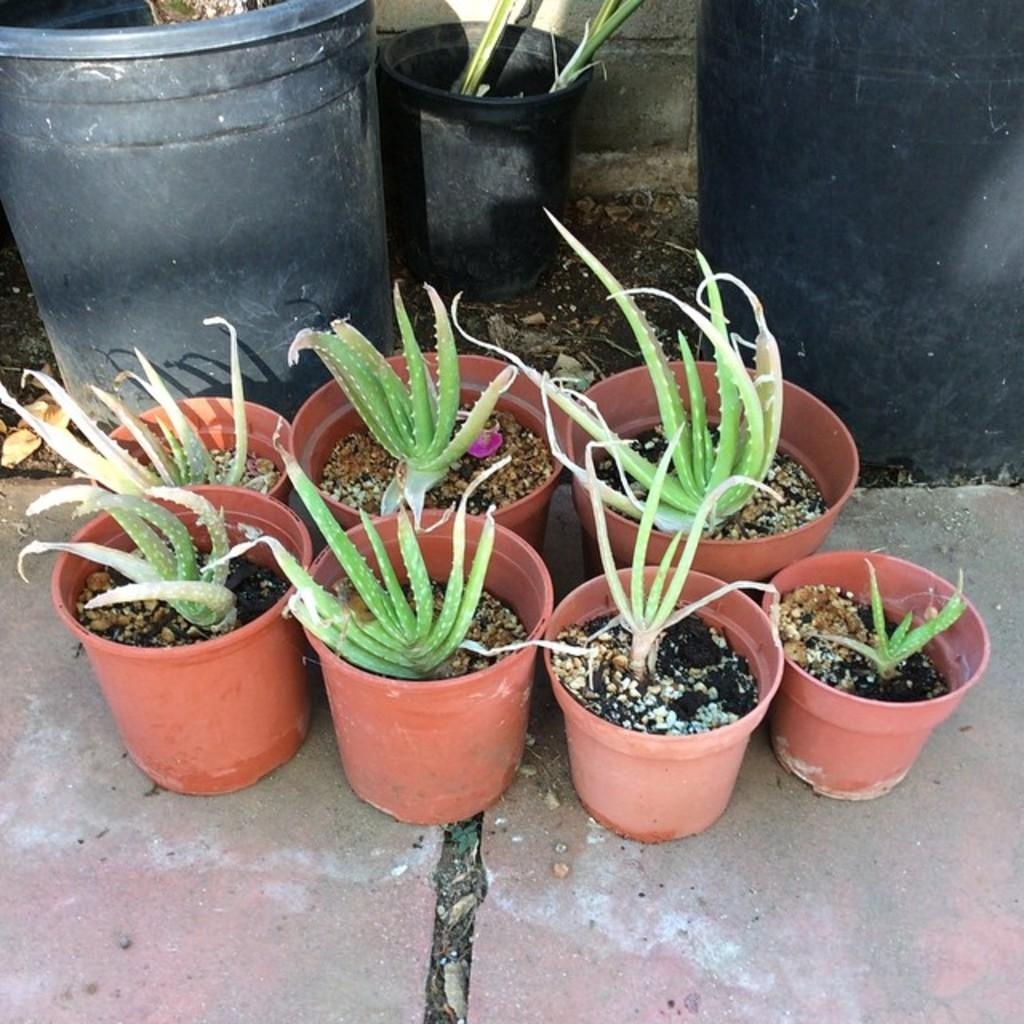What color are the flower pots in the image? There are brown and black color flower pots in the image. What type of plants are in the flower pots? There are green color aloe Vera plants in the flower pots. What is the surface visible in the image? There is a floor visible in the image. Where is the lunchroom located in the image? There is no mention of a lunchroom in the image; it only features flower pots and plants. Can you see a fan in the image? There is no fan visible in the image. 